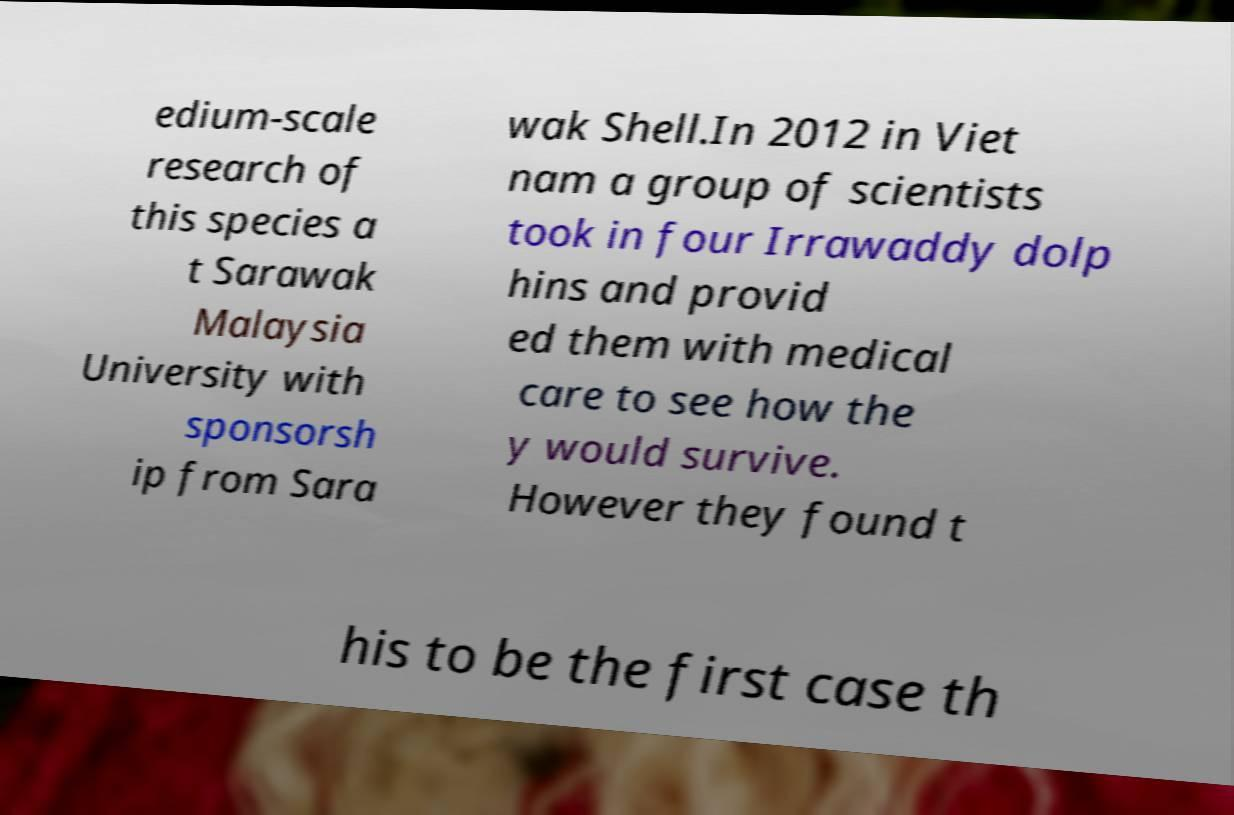There's text embedded in this image that I need extracted. Can you transcribe it verbatim? edium-scale research of this species a t Sarawak Malaysia University with sponsorsh ip from Sara wak Shell.In 2012 in Viet nam a group of scientists took in four Irrawaddy dolp hins and provid ed them with medical care to see how the y would survive. However they found t his to be the first case th 